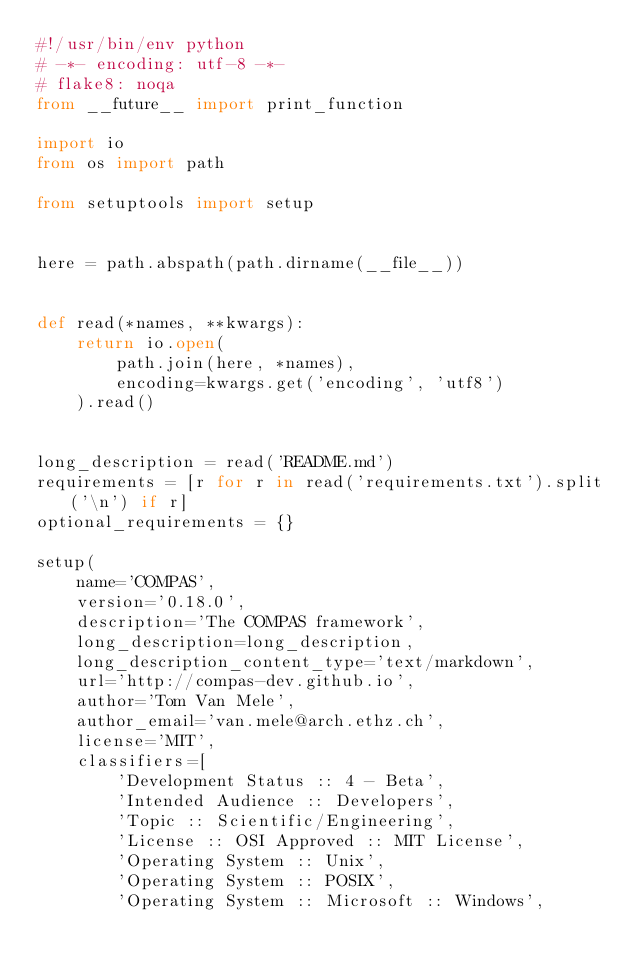<code> <loc_0><loc_0><loc_500><loc_500><_Python_>#!/usr/bin/env python
# -*- encoding: utf-8 -*-
# flake8: noqa
from __future__ import print_function

import io
from os import path

from setuptools import setup


here = path.abspath(path.dirname(__file__))


def read(*names, **kwargs):
    return io.open(
        path.join(here, *names),
        encoding=kwargs.get('encoding', 'utf8')
    ).read()


long_description = read('README.md')
requirements = [r for r in read('requirements.txt').split('\n') if r]
optional_requirements = {}

setup(
    name='COMPAS',
    version='0.18.0',
    description='The COMPAS framework',
    long_description=long_description,
    long_description_content_type='text/markdown',
    url='http://compas-dev.github.io',
    author='Tom Van Mele',
    author_email='van.mele@arch.ethz.ch',
    license='MIT',
    classifiers=[
        'Development Status :: 4 - Beta',
        'Intended Audience :: Developers',
        'Topic :: Scientific/Engineering',
        'License :: OSI Approved :: MIT License',
        'Operating System :: Unix',
        'Operating System :: POSIX',
        'Operating System :: Microsoft :: Windows',</code> 